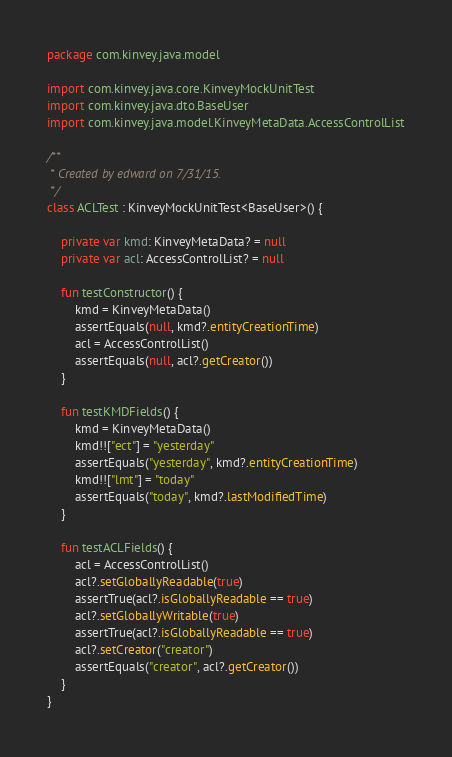<code> <loc_0><loc_0><loc_500><loc_500><_Kotlin_>package com.kinvey.java.model

import com.kinvey.java.core.KinveyMockUnitTest
import com.kinvey.java.dto.BaseUser
import com.kinvey.java.model.KinveyMetaData.AccessControlList

/**
 * Created by edward on 7/31/15.
 */
class ACLTest : KinveyMockUnitTest<BaseUser>() {

    private var kmd: KinveyMetaData? = null
    private var acl: AccessControlList? = null

    fun testConstructor() {
        kmd = KinveyMetaData()
        assertEquals(null, kmd?.entityCreationTime)
        acl = AccessControlList()
        assertEquals(null, acl?.getCreator())
    }

    fun testKMDFields() {
        kmd = KinveyMetaData()
        kmd!!["ect"] = "yesterday"
        assertEquals("yesterday", kmd?.entityCreationTime)
        kmd!!["lmt"] = "today"
        assertEquals("today", kmd?.lastModifiedTime)
    }

    fun testACLFields() {
        acl = AccessControlList()
        acl?.setGloballyReadable(true)
        assertTrue(acl?.isGloballyReadable == true)
        acl?.setGloballyWritable(true)
        assertTrue(acl?.isGloballyReadable == true)
        acl?.setCreator("creator")
        assertEquals("creator", acl?.getCreator())
    }
}</code> 